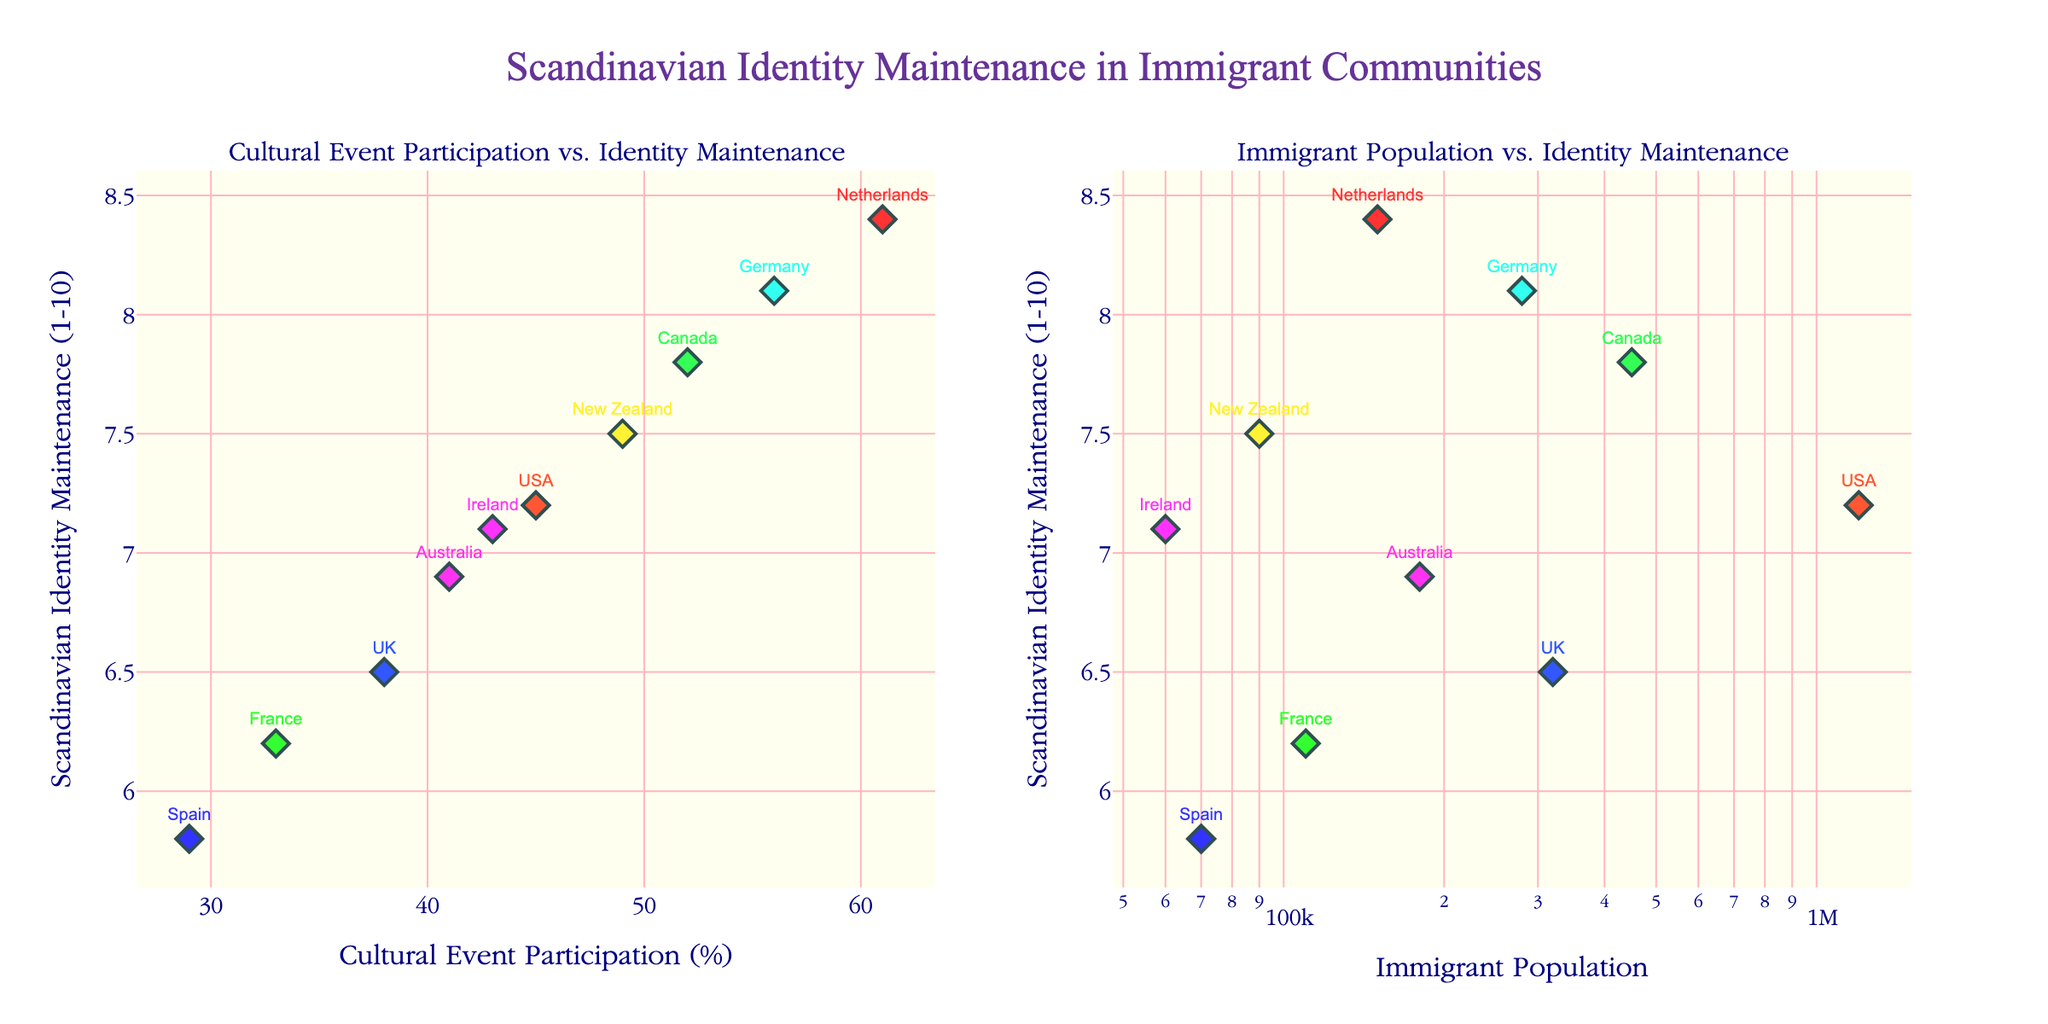What's the main title of the figure? The title of the figure is located at the top center and provides a summary of what the figure represents.
Answer: Scandinavian Identity Maintenance in Immigrant Communities How many data points are shown in each subplot? Each subplot contains a data point for each country listed in the dataset. Let's count the countries: USA, Canada, UK, Australia, Germany, New Zealand, Netherlands, France, Spain, Ireland. That makes 10 data points in each subplot.
Answer: 10 Which country has the highest Scandinavian identity maintenance score, and what is that score? In the subplot on the left (Cultural Event Participation vs. Identity Maintenance), the country with the highest Scandinavian identity maintenance score is the one with the highest position on the y-axis. From the data points, Germany has the highest score of 8.1.
Answer: Germany, 8.1 Which country has the lowest participation in cultural events but a relatively high Scandinavian identity maintenance score? In the subplot for Cultural Event Participation vs. Identity Maintenance, look for the country with the lowest position on the x-axis but a high position on the y-axis. France has the lowest participation at 33%, yet a reasonably high identity maintenance score of 6.2.
Answer: France Compare the relationship between Cultural Event Participation and Scandinavian Identity Maintenance for the USA and Canada. Which country scores higher on both metrics? On the left subplot, the USA has a Cultural Event Participation of 45% and an identity maintenance score of 7.2, whereas Canada has 52% participation and a 7.8 score. Thus, Canada scores higher in both metrics.
Answer: Canada Is there a visible trend between Cultural Event Participation and Scandinavian Identity Maintenance? In the subplot for Cultural Event Participation vs. Identity Maintenance, observe the general direction of the data points. As participation increases from left to right, the identity maintenance scores generally appear to increase as well, indicating a positive correlation.
Answer: Positive correlation In the Immigrant Population vs. Identity Maintenance subplot, which country with the lowest immigrant population has the highest identity maintenance score? In the right subplot, identify the country with the lowest position on the x-axis (smallest population) and the highest position on the y-axis (highest identity maintenance score). New Zealand has the smallest population (90,000) and a relatively high identity maintenance score (7.5).
Answer: New Zealand What is the approximate range of Scandinavian Identity Maintenance scores? The Y-axis on both subplots represents the Scandinavian Identity Maintenance scores. The lowest score appears to be 5.8 (Spain), and the highest is 8.4 (Netherlands), giving a range from 5.8 to 8.4.
Answer: 5.8 to 8.4 Which axis is scaled logarithmically, and why might this be useful? The x-axis of the right subplot (Immigrant Population vs. Identity Maintenance) is scaled logarithmically. This helps to better visualize data points that vary greatly in magnitude, such as immigrant population numbers.
Answer: Immigrant Population axis on the right subplot Does the country with the highest immigrant population also have the highest Scandinavian identity maintenance score? In the right subplot, the country with the highest immigrant population (x-axis) is the USA (1,200,000), but the highest identity maintenance score (y-axis) is 8.4 from the Netherlands. Therefore, the country with the highest immigrant population does not have the highest identity maintenance score.
Answer: No 